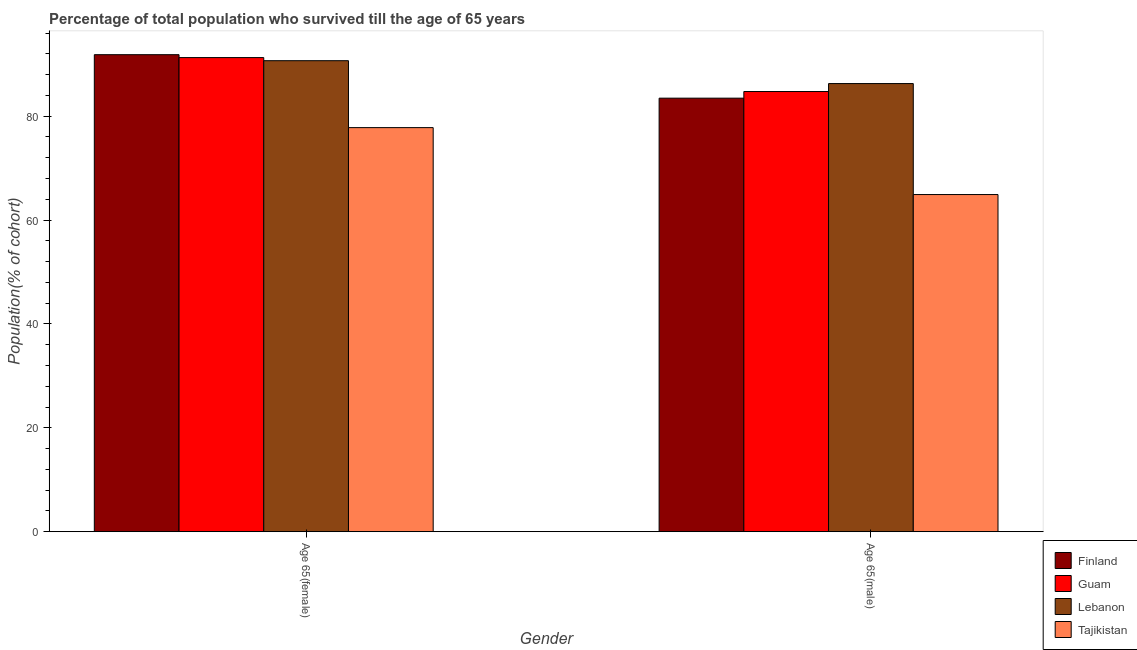How many different coloured bars are there?
Your response must be concise. 4. Are the number of bars per tick equal to the number of legend labels?
Provide a short and direct response. Yes. How many bars are there on the 2nd tick from the left?
Offer a terse response. 4. How many bars are there on the 1st tick from the right?
Your response must be concise. 4. What is the label of the 2nd group of bars from the left?
Ensure brevity in your answer.  Age 65(male). What is the percentage of male population who survived till age of 65 in Finland?
Ensure brevity in your answer.  83.46. Across all countries, what is the maximum percentage of male population who survived till age of 65?
Ensure brevity in your answer.  86.27. Across all countries, what is the minimum percentage of male population who survived till age of 65?
Your answer should be compact. 64.91. In which country was the percentage of male population who survived till age of 65 maximum?
Make the answer very short. Lebanon. In which country was the percentage of female population who survived till age of 65 minimum?
Offer a terse response. Tajikistan. What is the total percentage of female population who survived till age of 65 in the graph?
Your response must be concise. 351.58. What is the difference between the percentage of male population who survived till age of 65 in Guam and that in Finland?
Give a very brief answer. 1.28. What is the difference between the percentage of male population who survived till age of 65 in Lebanon and the percentage of female population who survived till age of 65 in Tajikistan?
Offer a terse response. 8.48. What is the average percentage of female population who survived till age of 65 per country?
Your answer should be very brief. 87.89. What is the difference between the percentage of male population who survived till age of 65 and percentage of female population who survived till age of 65 in Guam?
Provide a succinct answer. -6.53. In how many countries, is the percentage of female population who survived till age of 65 greater than 52 %?
Make the answer very short. 4. What is the ratio of the percentage of male population who survived till age of 65 in Guam to that in Finland?
Offer a very short reply. 1.02. In how many countries, is the percentage of male population who survived till age of 65 greater than the average percentage of male population who survived till age of 65 taken over all countries?
Your answer should be very brief. 3. What does the 3rd bar from the left in Age 65(female) represents?
Offer a terse response. Lebanon. What does the 1st bar from the right in Age 65(female) represents?
Offer a very short reply. Tajikistan. How many bars are there?
Offer a terse response. 8. Are all the bars in the graph horizontal?
Offer a very short reply. No. What is the difference between two consecutive major ticks on the Y-axis?
Keep it short and to the point. 20. Are the values on the major ticks of Y-axis written in scientific E-notation?
Make the answer very short. No. How many legend labels are there?
Offer a terse response. 4. How are the legend labels stacked?
Offer a very short reply. Vertical. What is the title of the graph?
Your answer should be very brief. Percentage of total population who survived till the age of 65 years. Does "Micronesia" appear as one of the legend labels in the graph?
Provide a short and direct response. No. What is the label or title of the X-axis?
Provide a short and direct response. Gender. What is the label or title of the Y-axis?
Your answer should be very brief. Population(% of cohort). What is the Population(% of cohort) in Finland in Age 65(female)?
Give a very brief answer. 91.84. What is the Population(% of cohort) of Guam in Age 65(female)?
Offer a very short reply. 91.27. What is the Population(% of cohort) of Lebanon in Age 65(female)?
Offer a terse response. 90.68. What is the Population(% of cohort) of Tajikistan in Age 65(female)?
Ensure brevity in your answer.  77.79. What is the Population(% of cohort) in Finland in Age 65(male)?
Your answer should be compact. 83.46. What is the Population(% of cohort) in Guam in Age 65(male)?
Ensure brevity in your answer.  84.74. What is the Population(% of cohort) of Lebanon in Age 65(male)?
Offer a very short reply. 86.27. What is the Population(% of cohort) in Tajikistan in Age 65(male)?
Ensure brevity in your answer.  64.91. Across all Gender, what is the maximum Population(% of cohort) in Finland?
Offer a terse response. 91.84. Across all Gender, what is the maximum Population(% of cohort) in Guam?
Ensure brevity in your answer.  91.27. Across all Gender, what is the maximum Population(% of cohort) in Lebanon?
Your response must be concise. 90.68. Across all Gender, what is the maximum Population(% of cohort) in Tajikistan?
Keep it short and to the point. 77.79. Across all Gender, what is the minimum Population(% of cohort) in Finland?
Provide a succinct answer. 83.46. Across all Gender, what is the minimum Population(% of cohort) in Guam?
Give a very brief answer. 84.74. Across all Gender, what is the minimum Population(% of cohort) in Lebanon?
Make the answer very short. 86.27. Across all Gender, what is the minimum Population(% of cohort) of Tajikistan?
Give a very brief answer. 64.91. What is the total Population(% of cohort) of Finland in the graph?
Offer a very short reply. 175.3. What is the total Population(% of cohort) in Guam in the graph?
Make the answer very short. 176.01. What is the total Population(% of cohort) in Lebanon in the graph?
Offer a terse response. 176.95. What is the total Population(% of cohort) in Tajikistan in the graph?
Ensure brevity in your answer.  142.7. What is the difference between the Population(% of cohort) of Finland in Age 65(female) and that in Age 65(male)?
Give a very brief answer. 8.37. What is the difference between the Population(% of cohort) of Guam in Age 65(female) and that in Age 65(male)?
Offer a very short reply. 6.53. What is the difference between the Population(% of cohort) in Lebanon in Age 65(female) and that in Age 65(male)?
Provide a short and direct response. 4.4. What is the difference between the Population(% of cohort) in Tajikistan in Age 65(female) and that in Age 65(male)?
Keep it short and to the point. 12.89. What is the difference between the Population(% of cohort) of Finland in Age 65(female) and the Population(% of cohort) of Guam in Age 65(male)?
Give a very brief answer. 7.09. What is the difference between the Population(% of cohort) in Finland in Age 65(female) and the Population(% of cohort) in Lebanon in Age 65(male)?
Offer a very short reply. 5.56. What is the difference between the Population(% of cohort) of Finland in Age 65(female) and the Population(% of cohort) of Tajikistan in Age 65(male)?
Provide a succinct answer. 26.93. What is the difference between the Population(% of cohort) in Guam in Age 65(female) and the Population(% of cohort) in Lebanon in Age 65(male)?
Your response must be concise. 5. What is the difference between the Population(% of cohort) of Guam in Age 65(female) and the Population(% of cohort) of Tajikistan in Age 65(male)?
Your response must be concise. 26.37. What is the difference between the Population(% of cohort) of Lebanon in Age 65(female) and the Population(% of cohort) of Tajikistan in Age 65(male)?
Your answer should be compact. 25.77. What is the average Population(% of cohort) of Finland per Gender?
Your response must be concise. 87.65. What is the average Population(% of cohort) in Guam per Gender?
Offer a terse response. 88.01. What is the average Population(% of cohort) of Lebanon per Gender?
Provide a short and direct response. 88.47. What is the average Population(% of cohort) in Tajikistan per Gender?
Offer a very short reply. 71.35. What is the difference between the Population(% of cohort) in Finland and Population(% of cohort) in Guam in Age 65(female)?
Keep it short and to the point. 0.56. What is the difference between the Population(% of cohort) of Finland and Population(% of cohort) of Lebanon in Age 65(female)?
Make the answer very short. 1.16. What is the difference between the Population(% of cohort) of Finland and Population(% of cohort) of Tajikistan in Age 65(female)?
Make the answer very short. 14.04. What is the difference between the Population(% of cohort) in Guam and Population(% of cohort) in Lebanon in Age 65(female)?
Make the answer very short. 0.6. What is the difference between the Population(% of cohort) of Guam and Population(% of cohort) of Tajikistan in Age 65(female)?
Your response must be concise. 13.48. What is the difference between the Population(% of cohort) of Lebanon and Population(% of cohort) of Tajikistan in Age 65(female)?
Your answer should be very brief. 12.88. What is the difference between the Population(% of cohort) in Finland and Population(% of cohort) in Guam in Age 65(male)?
Give a very brief answer. -1.28. What is the difference between the Population(% of cohort) of Finland and Population(% of cohort) of Lebanon in Age 65(male)?
Keep it short and to the point. -2.81. What is the difference between the Population(% of cohort) of Finland and Population(% of cohort) of Tajikistan in Age 65(male)?
Your answer should be compact. 18.56. What is the difference between the Population(% of cohort) in Guam and Population(% of cohort) in Lebanon in Age 65(male)?
Provide a short and direct response. -1.53. What is the difference between the Population(% of cohort) of Guam and Population(% of cohort) of Tajikistan in Age 65(male)?
Make the answer very short. 19.83. What is the difference between the Population(% of cohort) in Lebanon and Population(% of cohort) in Tajikistan in Age 65(male)?
Your answer should be very brief. 21.37. What is the ratio of the Population(% of cohort) in Finland in Age 65(female) to that in Age 65(male)?
Offer a terse response. 1.1. What is the ratio of the Population(% of cohort) of Guam in Age 65(female) to that in Age 65(male)?
Offer a very short reply. 1.08. What is the ratio of the Population(% of cohort) in Lebanon in Age 65(female) to that in Age 65(male)?
Provide a short and direct response. 1.05. What is the ratio of the Population(% of cohort) in Tajikistan in Age 65(female) to that in Age 65(male)?
Make the answer very short. 1.2. What is the difference between the highest and the second highest Population(% of cohort) in Finland?
Offer a terse response. 8.37. What is the difference between the highest and the second highest Population(% of cohort) in Guam?
Provide a short and direct response. 6.53. What is the difference between the highest and the second highest Population(% of cohort) in Lebanon?
Your response must be concise. 4.4. What is the difference between the highest and the second highest Population(% of cohort) of Tajikistan?
Keep it short and to the point. 12.89. What is the difference between the highest and the lowest Population(% of cohort) of Finland?
Offer a terse response. 8.37. What is the difference between the highest and the lowest Population(% of cohort) in Guam?
Offer a terse response. 6.53. What is the difference between the highest and the lowest Population(% of cohort) of Lebanon?
Your response must be concise. 4.4. What is the difference between the highest and the lowest Population(% of cohort) of Tajikistan?
Provide a short and direct response. 12.89. 